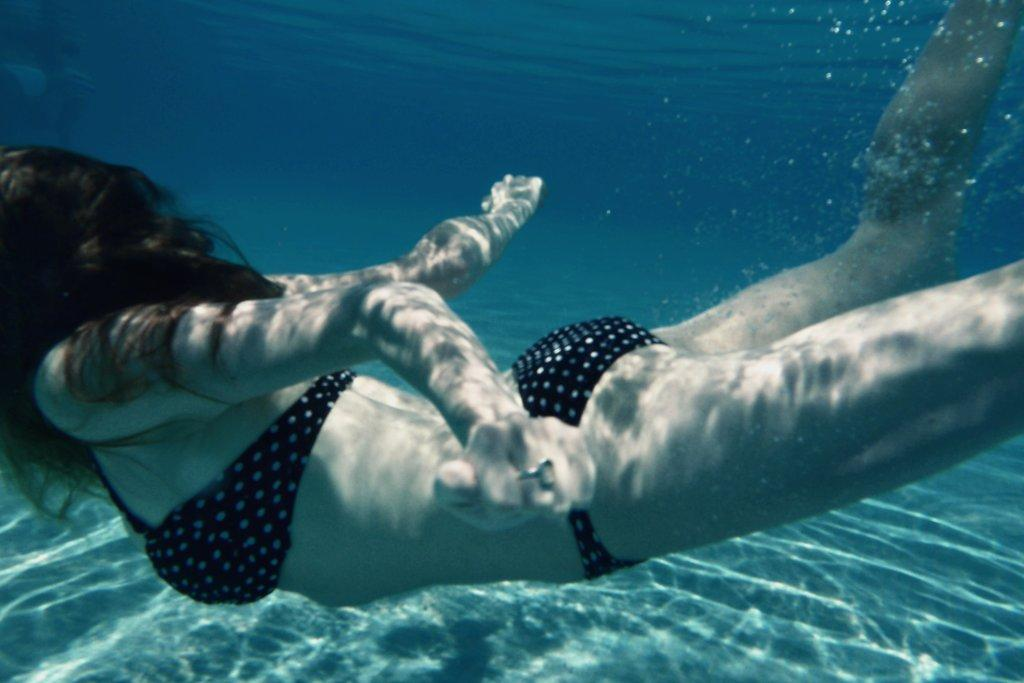Who is the main subject in the image? There is a lady in the image. What is the lady doing in the image? The lady is swimming in the water. What type of cave can be seen in the background of the image? There is no cave present in the image; it features a lady swimming in the water. What role does the lady play as a spy in the image? There is no indication in the image that the lady is a spy, as the image only shows her swimming in the water. 